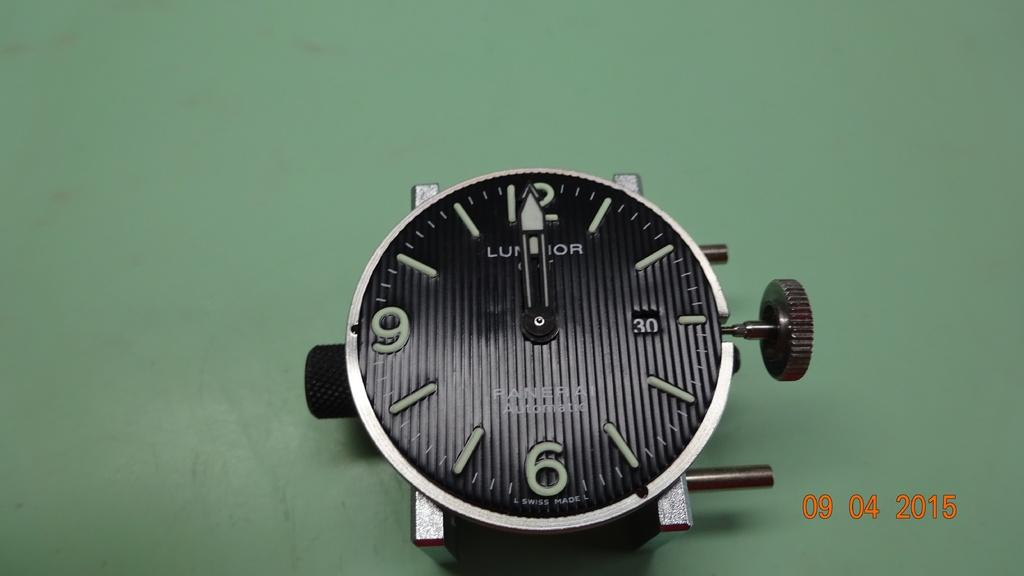Provide a one-sentence caption for the provided image. The black watch is from the brand Luminor. 